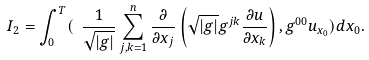<formula> <loc_0><loc_0><loc_500><loc_500>I _ { 2 } = \int _ { 0 } ^ { T } ( \ \frac { 1 } { \sqrt { | g | } } \sum _ { j , k = 1 } ^ { n } \frac { \partial } { \partial x _ { j } } \left ( \sqrt { | g | } g ^ { j k } \frac { \partial u } { \partial x _ { k } } \right ) , g ^ { 0 0 } u _ { x _ { 0 } } ) d x _ { 0 } .</formula> 